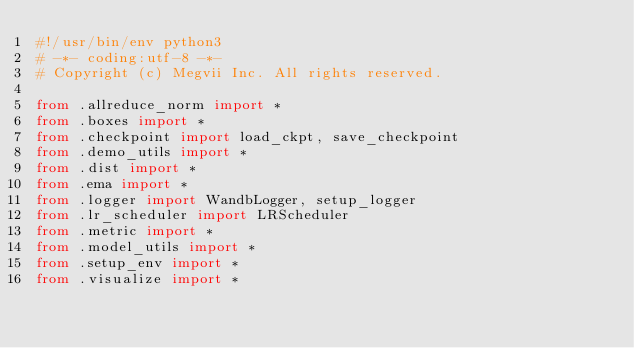Convert code to text. <code><loc_0><loc_0><loc_500><loc_500><_Python_>#!/usr/bin/env python3
# -*- coding:utf-8 -*-
# Copyright (c) Megvii Inc. All rights reserved.

from .allreduce_norm import *
from .boxes import *
from .checkpoint import load_ckpt, save_checkpoint
from .demo_utils import *
from .dist import *
from .ema import *
from .logger import WandbLogger, setup_logger
from .lr_scheduler import LRScheduler
from .metric import *
from .model_utils import *
from .setup_env import *
from .visualize import *
</code> 